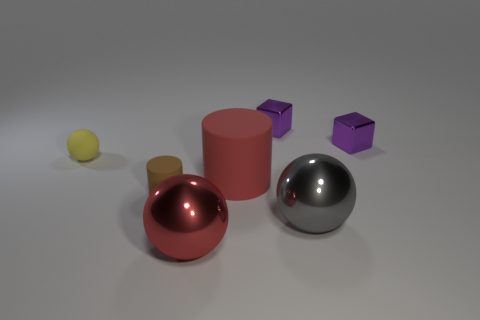How many things are either tiny metallic things that are on the right side of the yellow ball or metallic balls?
Offer a very short reply. 4. How many other objects are there of the same color as the small matte cylinder?
Offer a very short reply. 0. Is the number of things that are in front of the big red sphere the same as the number of small red metallic cylinders?
Ensure brevity in your answer.  Yes. There is a matte object behind the big red thing behind the gray object; what number of large rubber cylinders are behind it?
Keep it short and to the point. 0. Are there any other things that have the same size as the gray shiny object?
Your answer should be very brief. Yes. There is a gray shiny thing; is it the same size as the red object that is behind the gray metallic object?
Make the answer very short. Yes. What number of big red things are there?
Offer a terse response. 2. Does the yellow rubber sphere that is on the left side of the big rubber object have the same size as the red thing in front of the brown cylinder?
Provide a succinct answer. No. The other matte object that is the same shape as the large rubber object is what color?
Make the answer very short. Brown. Does the small brown rubber object have the same shape as the yellow object?
Offer a very short reply. No. 